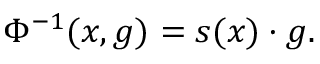<formula> <loc_0><loc_0><loc_500><loc_500>\Phi ^ { - 1 } ( x , g ) = s ( x ) \cdot g .</formula> 